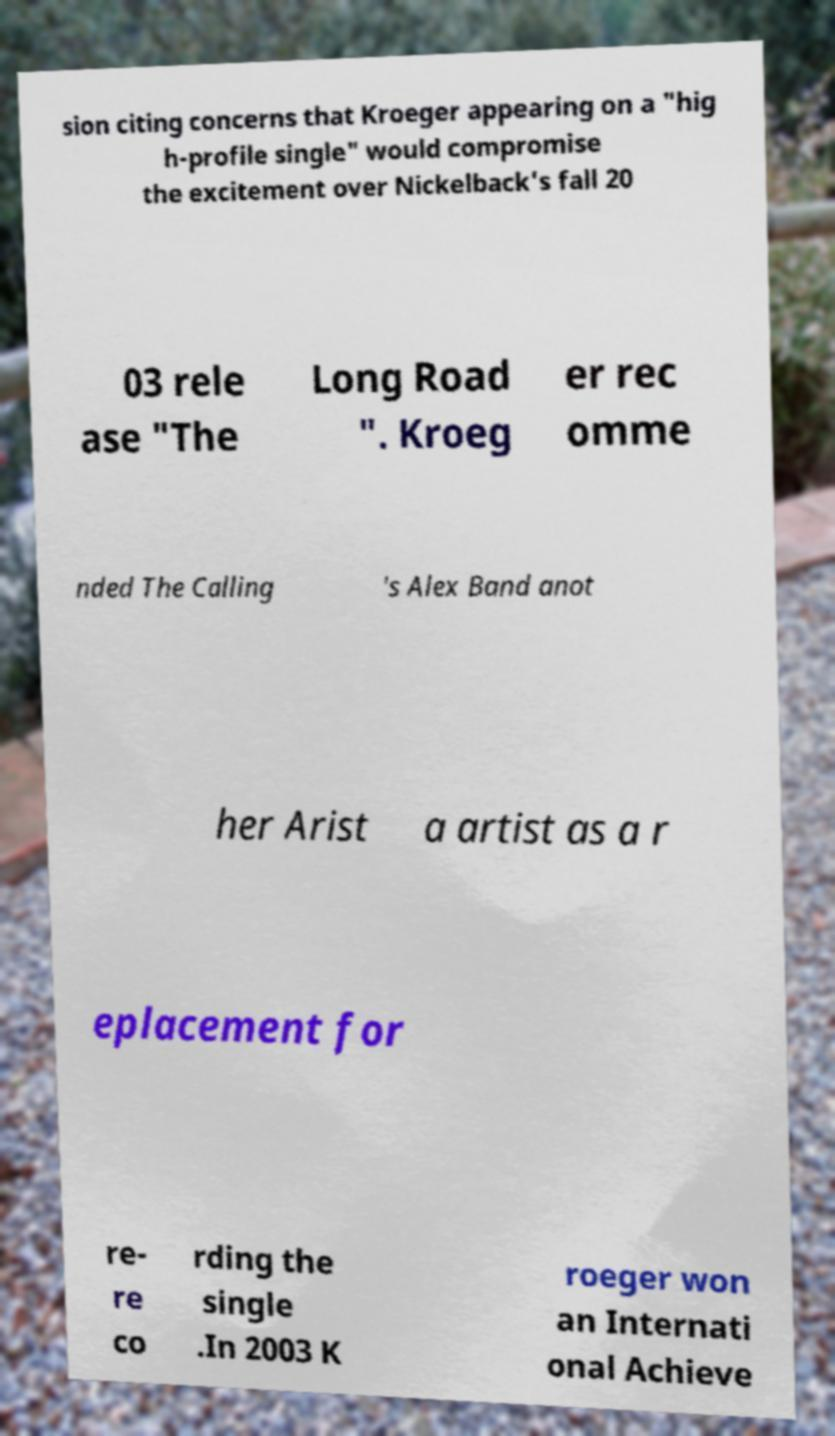For documentation purposes, I need the text within this image transcribed. Could you provide that? sion citing concerns that Kroeger appearing on a "hig h-profile single" would compromise the excitement over Nickelback's fall 20 03 rele ase "The Long Road ". Kroeg er rec omme nded The Calling 's Alex Band anot her Arist a artist as a r eplacement for re- re co rding the single .In 2003 K roeger won an Internati onal Achieve 